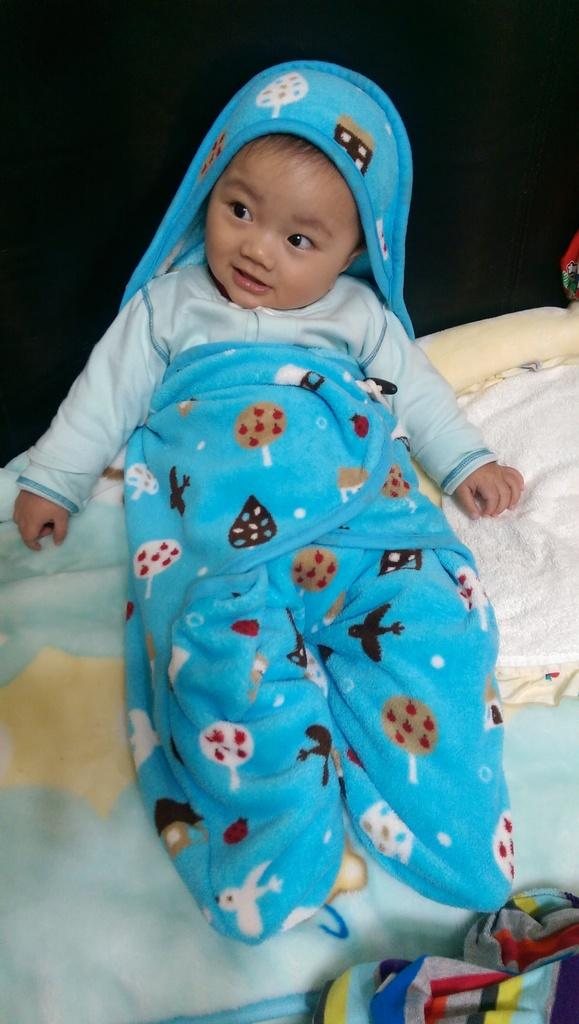What is the main subject of the image? The main subject of the image is a kid. What is the kid wearing in the image? The kid is wearing a bathrobe in the image. Where is the kid located in the image? The kid is sitting on a bed in the image. In which direction is the kid facing in the image? The provided facts do not mention the direction the kid is facing, so it cannot be determined from the image. 